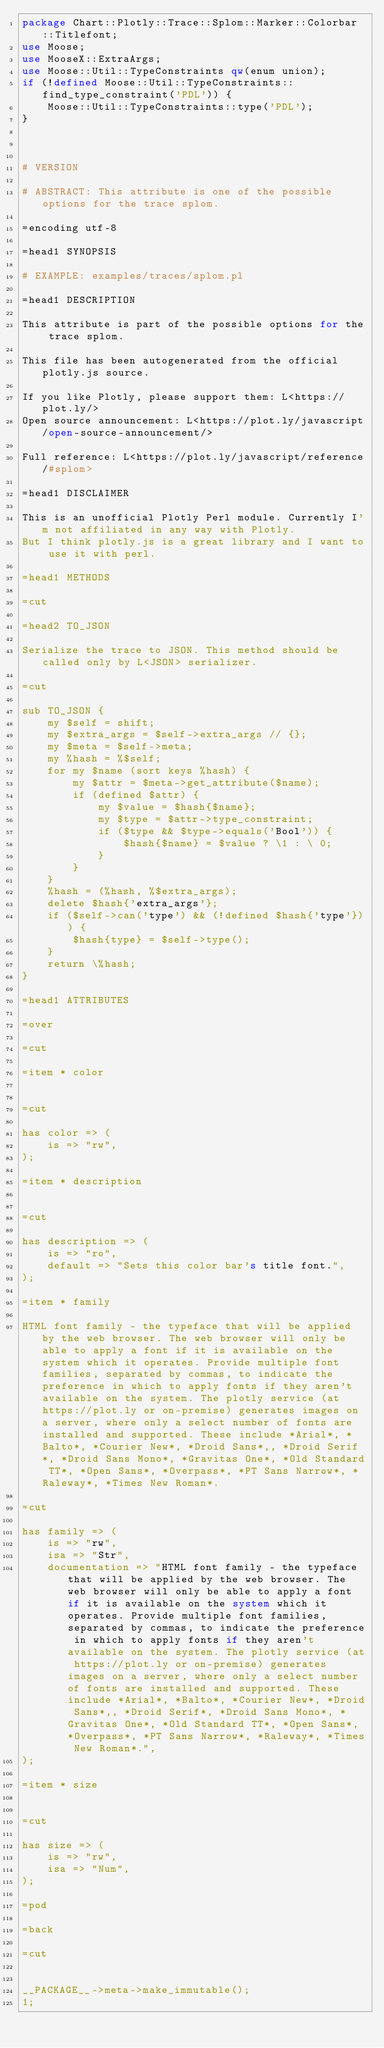<code> <loc_0><loc_0><loc_500><loc_500><_Perl_>package Chart::Plotly::Trace::Splom::Marker::Colorbar::Titlefont;
use Moose;
use MooseX::ExtraArgs;
use Moose::Util::TypeConstraints qw(enum union);
if (!defined Moose::Util::TypeConstraints::find_type_constraint('PDL')) {
    Moose::Util::TypeConstraints::type('PDL');
}



# VERSION

# ABSTRACT: This attribute is one of the possible options for the trace splom.

=encoding utf-8

=head1 SYNOPSIS

# EXAMPLE: examples/traces/splom.pl

=head1 DESCRIPTION

This attribute is part of the possible options for the trace splom.

This file has been autogenerated from the official plotly.js source.

If you like Plotly, please support them: L<https://plot.ly/> 
Open source announcement: L<https://plot.ly/javascript/open-source-announcement/>

Full reference: L<https://plot.ly/javascript/reference/#splom>

=head1 DISCLAIMER

This is an unofficial Plotly Perl module. Currently I'm not affiliated in any way with Plotly. 
But I think plotly.js is a great library and I want to use it with perl.

=head1 METHODS

=cut

=head2 TO_JSON

Serialize the trace to JSON. This method should be called only by L<JSON> serializer.

=cut

sub TO_JSON {
    my $self = shift; 
    my $extra_args = $self->extra_args // {};
    my $meta = $self->meta;
    my %hash = %$self;
    for my $name (sort keys %hash) {
        my $attr = $meta->get_attribute($name);
        if (defined $attr) {
            my $value = $hash{$name};
            my $type = $attr->type_constraint;
            if ($type && $type->equals('Bool')) {
                $hash{$name} = $value ? \1 : \ 0;
            }
        }
    }
    %hash = (%hash, %$extra_args);
    delete $hash{'extra_args'};
    if ($self->can('type') && (!defined $hash{'type'})) {
        $hash{type} = $self->type();
    }
    return \%hash;
}

=head1 ATTRIBUTES

=over

=cut

=item * color


=cut

has color => (
    is => "rw",
);

=item * description


=cut

has description => (
    is => "ro",
    default => "Sets this color bar's title font.",
);

=item * family

HTML font family - the typeface that will be applied by the web browser. The web browser will only be able to apply a font if it is available on the system which it operates. Provide multiple font families, separated by commas, to indicate the preference in which to apply fonts if they aren't available on the system. The plotly service (at https://plot.ly or on-premise) generates images on a server, where only a select number of fonts are installed and supported. These include *Arial*, *Balto*, *Courier New*, *Droid Sans*,, *Droid Serif*, *Droid Sans Mono*, *Gravitas One*, *Old Standard TT*, *Open Sans*, *Overpass*, *PT Sans Narrow*, *Raleway*, *Times New Roman*.

=cut

has family => (
    is => "rw",
    isa => "Str",
    documentation => "HTML font family - the typeface that will be applied by the web browser. The web browser will only be able to apply a font if it is available on the system which it operates. Provide multiple font families, separated by commas, to indicate the preference in which to apply fonts if they aren't available on the system. The plotly service (at https://plot.ly or on-premise) generates images on a server, where only a select number of fonts are installed and supported. These include *Arial*, *Balto*, *Courier New*, *Droid Sans*,, *Droid Serif*, *Droid Sans Mono*, *Gravitas One*, *Old Standard TT*, *Open Sans*, *Overpass*, *PT Sans Narrow*, *Raleway*, *Times New Roman*.",
);

=item * size


=cut

has size => (
    is => "rw",
    isa => "Num",
);

=pod

=back

=cut


__PACKAGE__->meta->make_immutable();
1;
</code> 